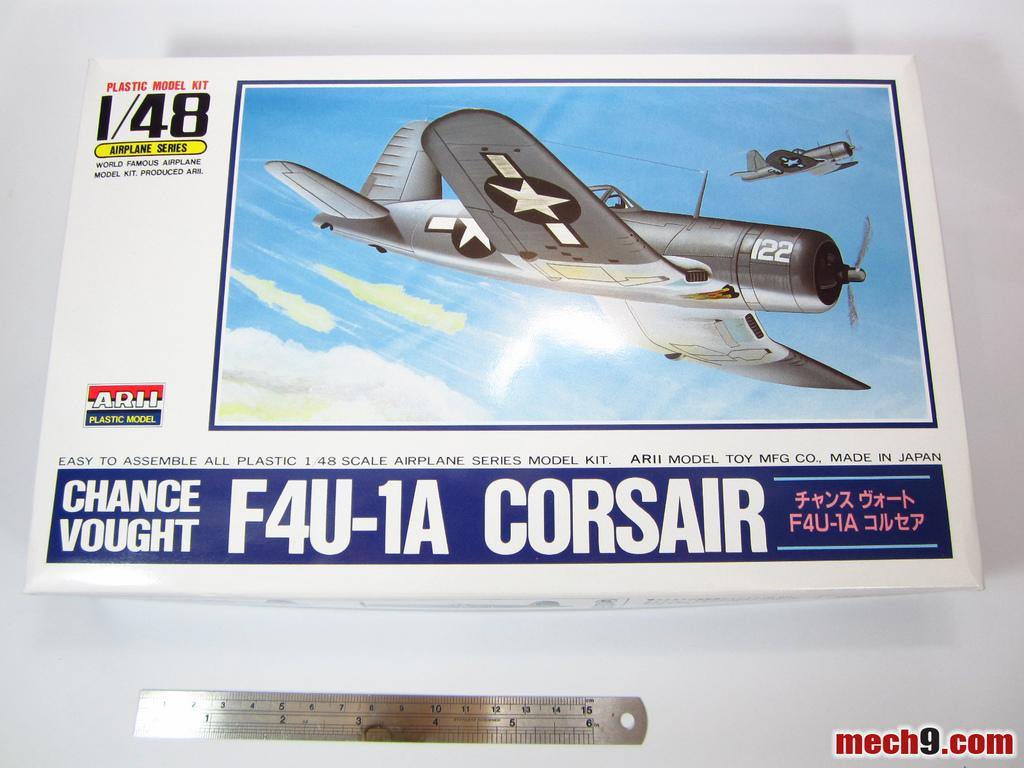<image>
Provide a brief description of the given image. An airplane model for an F4U-1A Corsair is made in Japan. 